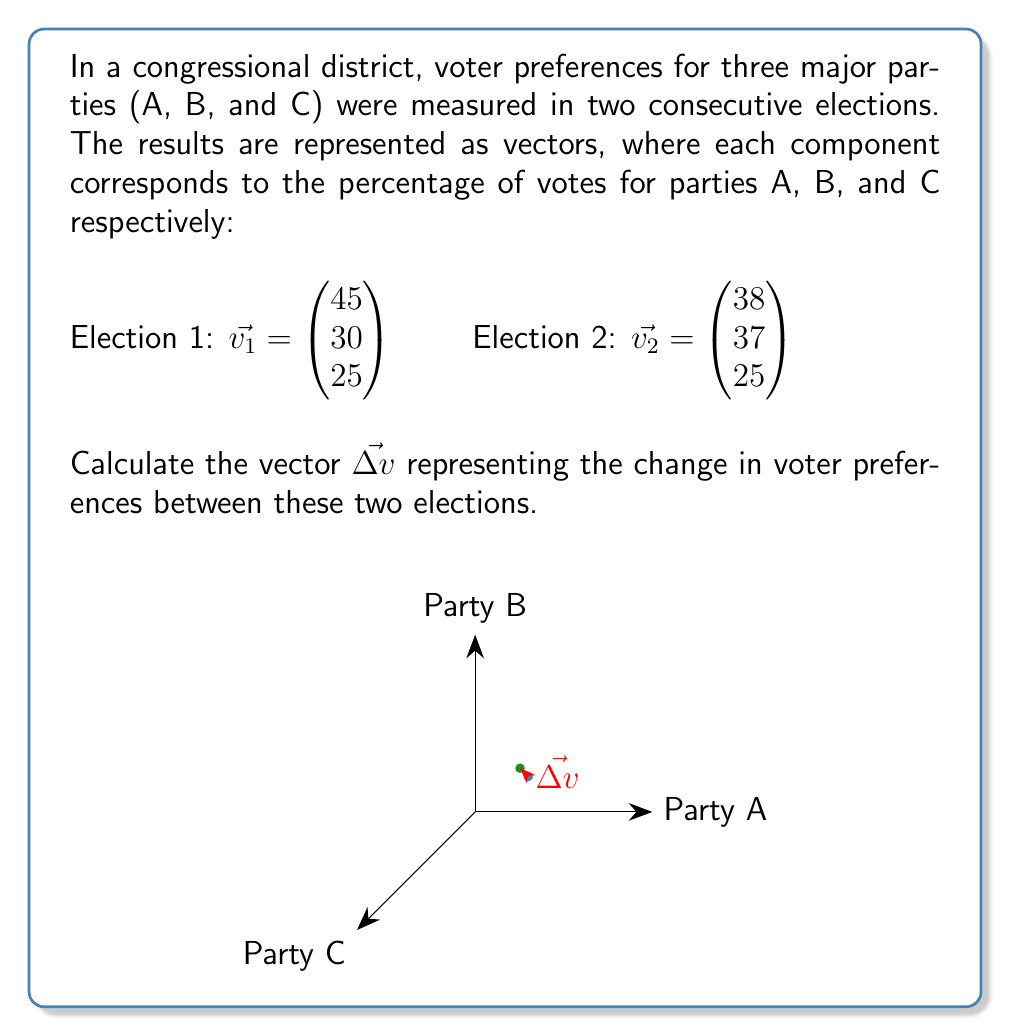Help me with this question. To calculate the change in voter preferences, we need to subtract the vector representing the first election from the vector representing the second election.

Let $\vec{\Delta v}$ be the vector representing the change:

$$\vec{\Delta v} = \vec{v_2} - \vec{v_1}$$

Substituting the given vectors:

$$\vec{\Delta v} = \begin{pmatrix} 38 \\ 37 \\ 25 \end{pmatrix} - \begin{pmatrix} 45 \\ 30 \\ 25 \end{pmatrix}$$

Performing the subtraction component-wise:

$$\vec{\Delta v} = \begin{pmatrix} 38 - 45 \\ 37 - 30 \\ 25 - 25 \end{pmatrix}$$

Simplifying:

$$\vec{\Delta v} = \begin{pmatrix} -7 \\ 7 \\ 0 \end{pmatrix}$$

This result shows that Party A lost 7% of the vote share, Party B gained 7% of the vote share, and Party C's vote share remained unchanged between the two elections.
Answer: $\vec{\Delta v} = \begin{pmatrix} -7 \\ 7 \\ 0 \end{pmatrix}$ 